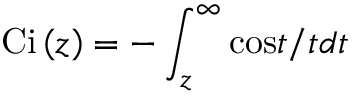<formula> <loc_0><loc_0><loc_500><loc_500>C i \left ( z \right ) = - \int _ { z } ^ { \infty } \cos t / t d t</formula> 